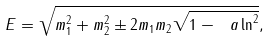Convert formula to latex. <formula><loc_0><loc_0><loc_500><loc_500>E = \sqrt { m _ { 1 } ^ { 2 } + m _ { 2 } ^ { 2 } \pm 2 m _ { 1 } m _ { 2 } \sqrt { 1 - \ a \ln ^ { 2 } } } ,</formula> 